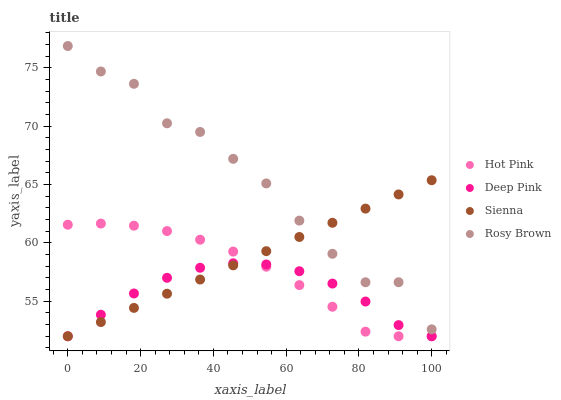Does Deep Pink have the minimum area under the curve?
Answer yes or no. Yes. Does Rosy Brown have the maximum area under the curve?
Answer yes or no. Yes. Does Hot Pink have the minimum area under the curve?
Answer yes or no. No. Does Hot Pink have the maximum area under the curve?
Answer yes or no. No. Is Sienna the smoothest?
Answer yes or no. Yes. Is Rosy Brown the roughest?
Answer yes or no. Yes. Is Hot Pink the smoothest?
Answer yes or no. No. Is Hot Pink the roughest?
Answer yes or no. No. Does Sienna have the lowest value?
Answer yes or no. Yes. Does Rosy Brown have the lowest value?
Answer yes or no. No. Does Rosy Brown have the highest value?
Answer yes or no. Yes. Does Hot Pink have the highest value?
Answer yes or no. No. Is Deep Pink less than Rosy Brown?
Answer yes or no. Yes. Is Rosy Brown greater than Deep Pink?
Answer yes or no. Yes. Does Sienna intersect Hot Pink?
Answer yes or no. Yes. Is Sienna less than Hot Pink?
Answer yes or no. No. Is Sienna greater than Hot Pink?
Answer yes or no. No. Does Deep Pink intersect Rosy Brown?
Answer yes or no. No. 